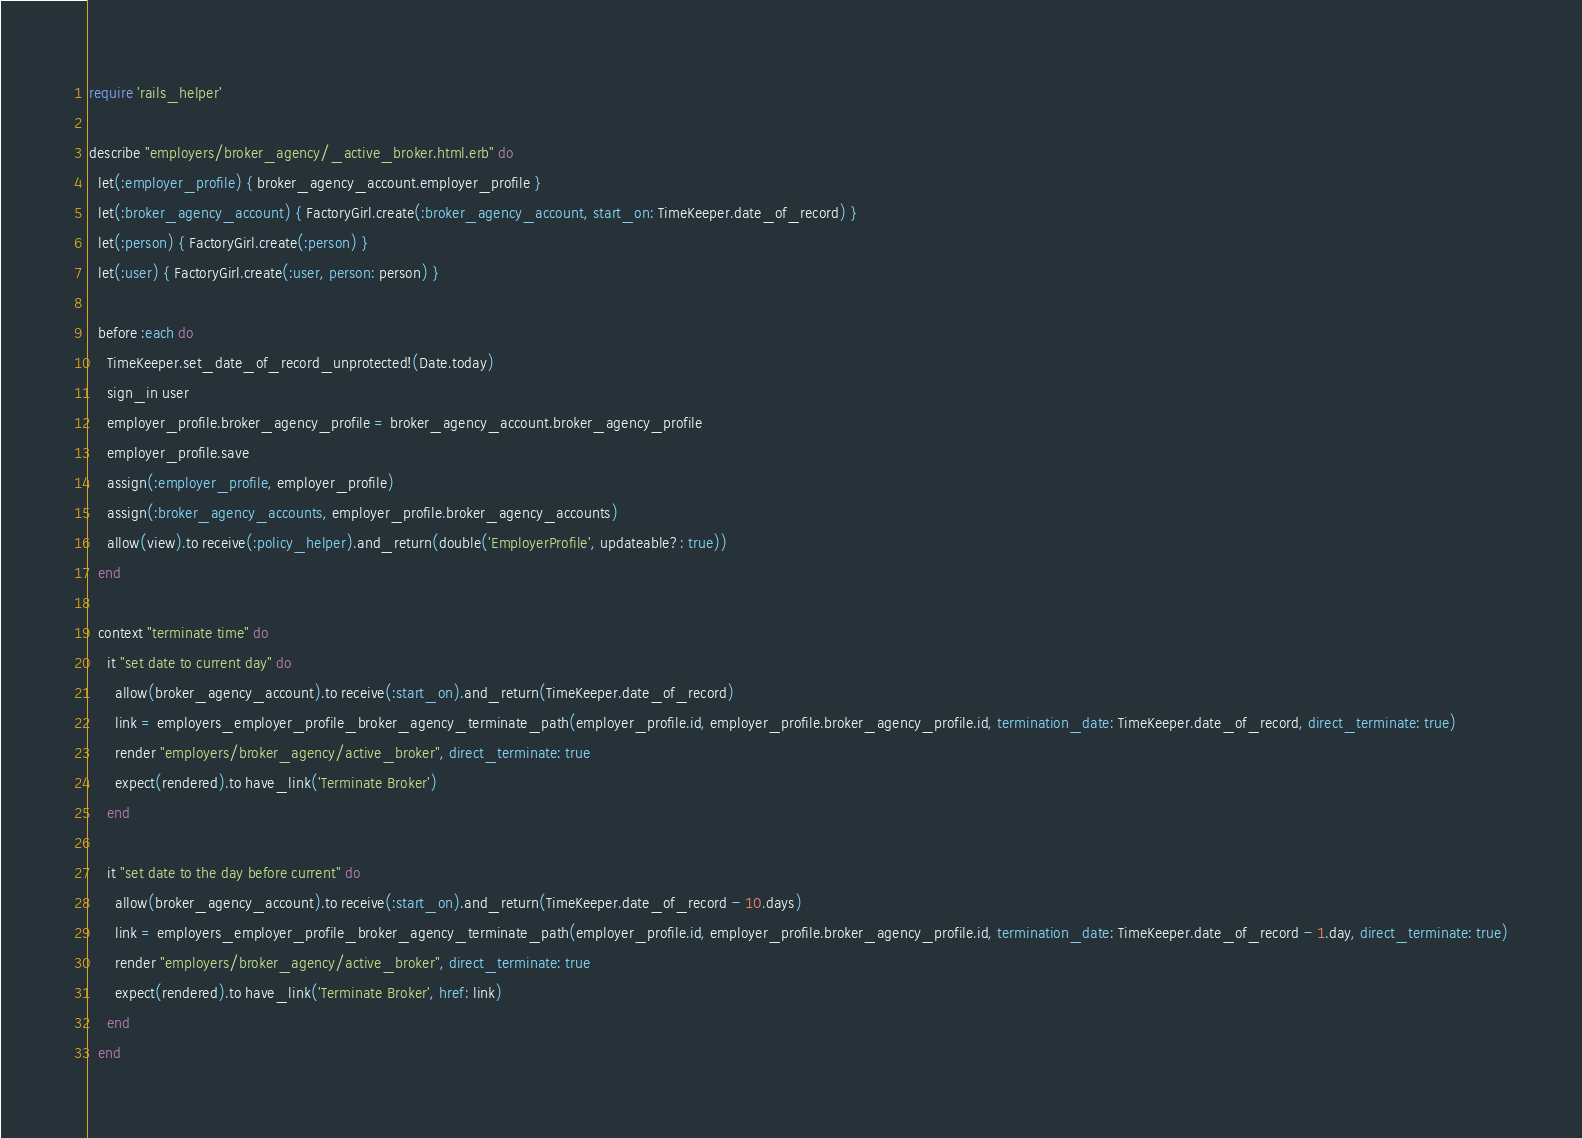Convert code to text. <code><loc_0><loc_0><loc_500><loc_500><_Ruby_>require 'rails_helper'

describe "employers/broker_agency/_active_broker.html.erb" do
  let(:employer_profile) { broker_agency_account.employer_profile }
  let(:broker_agency_account) { FactoryGirl.create(:broker_agency_account, start_on: TimeKeeper.date_of_record) }
  let(:person) { FactoryGirl.create(:person) }
  let(:user) { FactoryGirl.create(:user, person: person) }

  before :each do
    TimeKeeper.set_date_of_record_unprotected!(Date.today)
    sign_in user
    employer_profile.broker_agency_profile = broker_agency_account.broker_agency_profile
    employer_profile.save
    assign(:employer_profile, employer_profile)
    assign(:broker_agency_accounts, employer_profile.broker_agency_accounts)
    allow(view).to receive(:policy_helper).and_return(double('EmployerProfile', updateable?: true))
  end

  context "terminate time" do
    it "set date to current day" do
      allow(broker_agency_account).to receive(:start_on).and_return(TimeKeeper.date_of_record)
      link = employers_employer_profile_broker_agency_terminate_path(employer_profile.id, employer_profile.broker_agency_profile.id, termination_date: TimeKeeper.date_of_record, direct_terminate: true)
      render "employers/broker_agency/active_broker", direct_terminate: true
      expect(rendered).to have_link('Terminate Broker')
    end

    it "set date to the day before current" do
      allow(broker_agency_account).to receive(:start_on).and_return(TimeKeeper.date_of_record - 10.days)
      link = employers_employer_profile_broker_agency_terminate_path(employer_profile.id, employer_profile.broker_agency_profile.id, termination_date: TimeKeeper.date_of_record - 1.day, direct_terminate: true)
      render "employers/broker_agency/active_broker", direct_terminate: true
      expect(rendered).to have_link('Terminate Broker', href: link)
    end
  end
</code> 